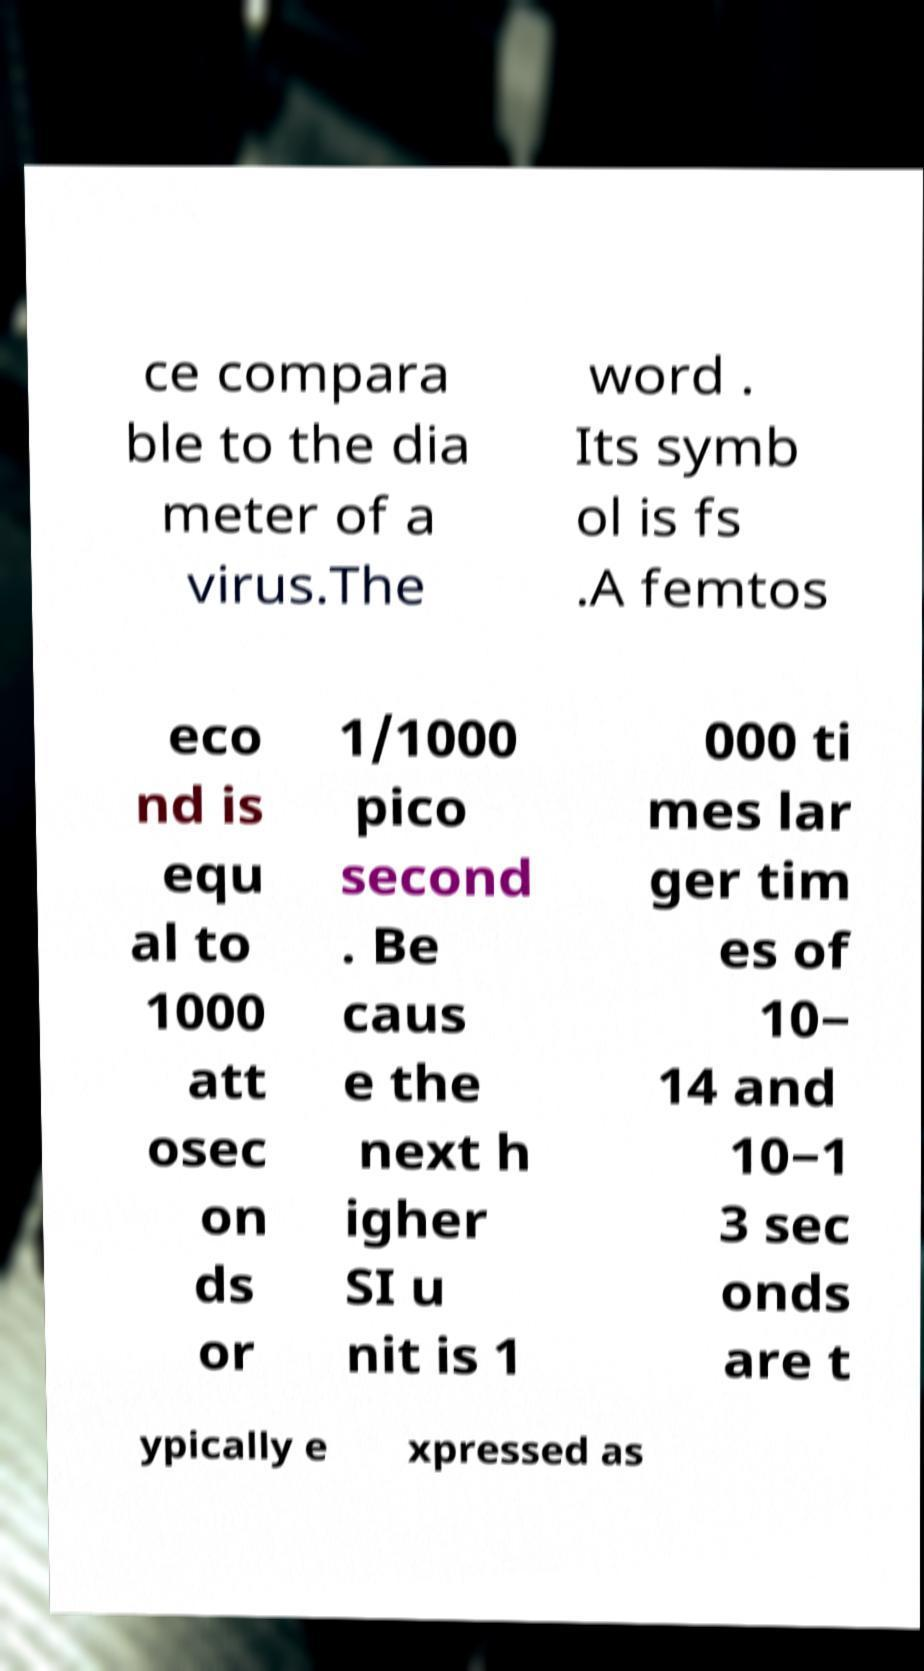For documentation purposes, I need the text within this image transcribed. Could you provide that? ce compara ble to the dia meter of a virus.The word . Its symb ol is fs .A femtos eco nd is equ al to 1000 att osec on ds or 1/1000 pico second . Be caus e the next h igher SI u nit is 1 000 ti mes lar ger tim es of 10− 14 and 10−1 3 sec onds are t ypically e xpressed as 